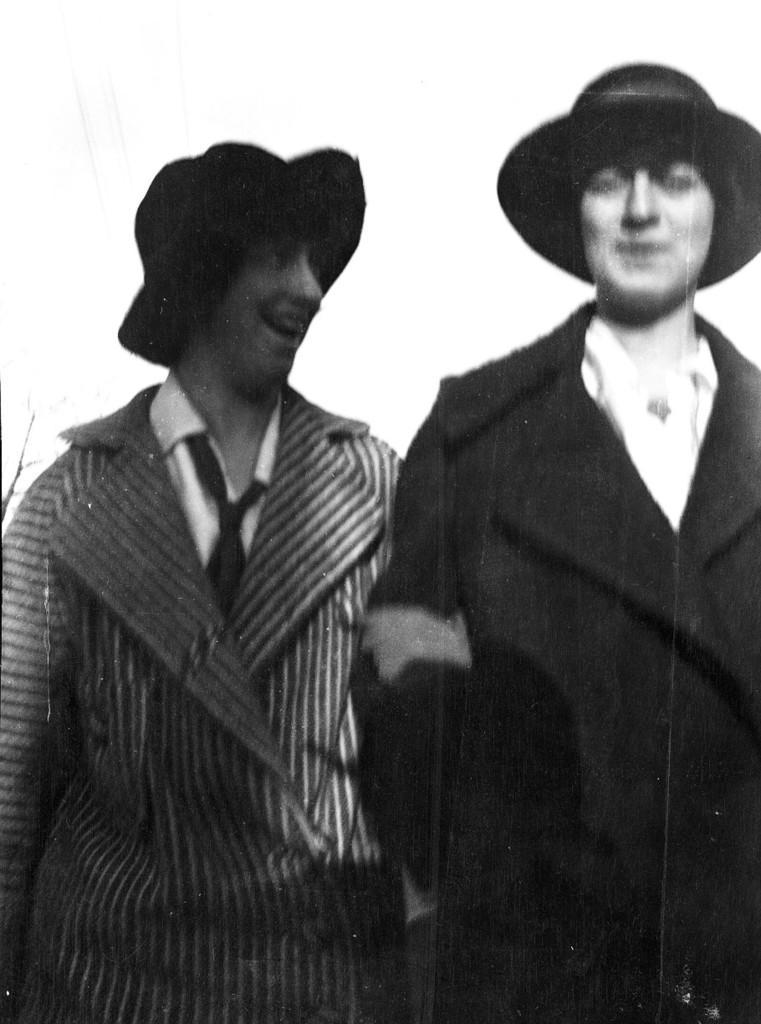Describe this image in one or two sentences. In this image, in the foreground we can see two people and both are wearing caps. 